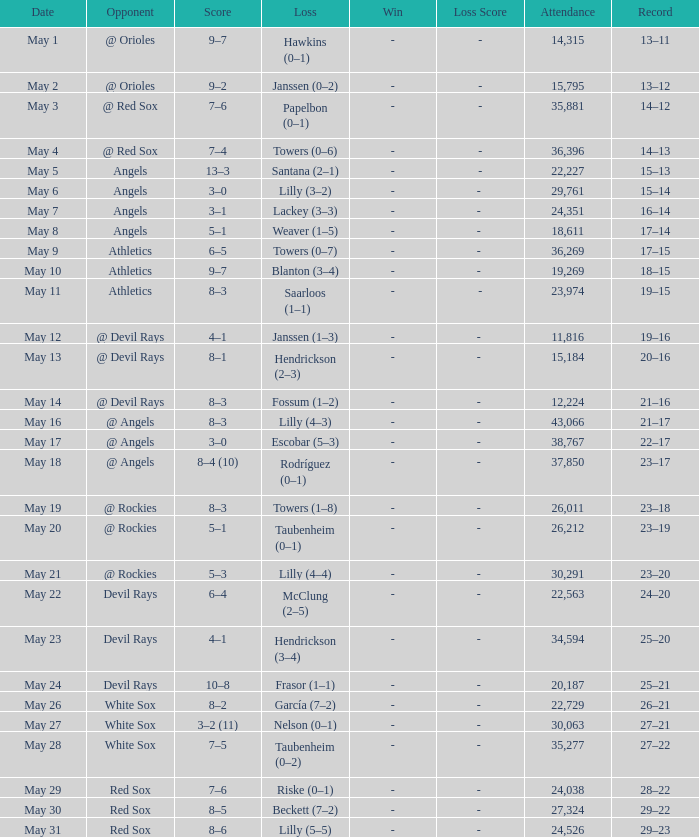What was the average attendance for games with a loss of papelbon (0–1)? 35881.0. 